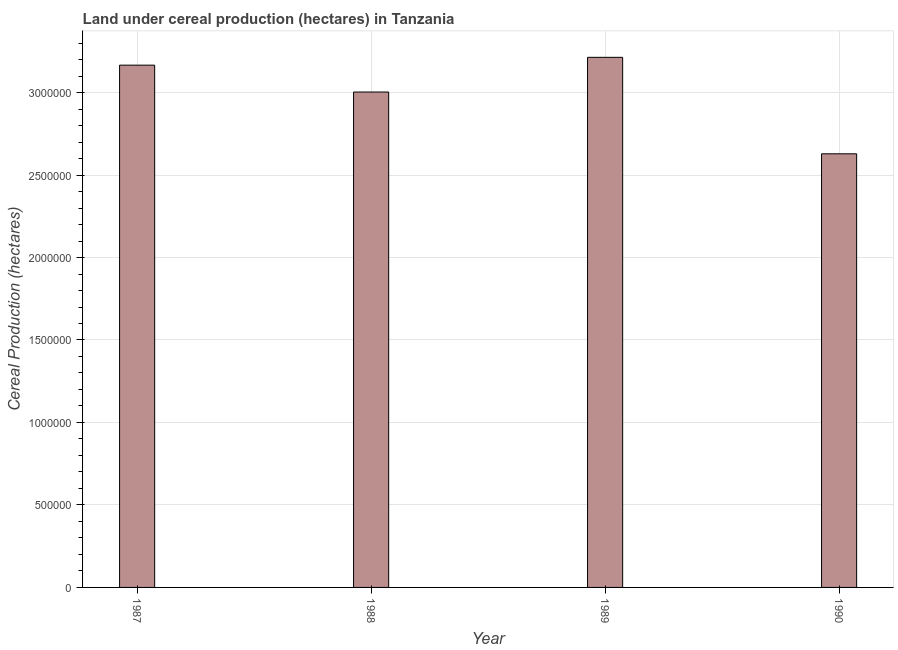Does the graph contain any zero values?
Make the answer very short. No. What is the title of the graph?
Your answer should be very brief. Land under cereal production (hectares) in Tanzania. What is the label or title of the X-axis?
Ensure brevity in your answer.  Year. What is the label or title of the Y-axis?
Keep it short and to the point. Cereal Production (hectares). What is the land under cereal production in 1988?
Ensure brevity in your answer.  3.00e+06. Across all years, what is the maximum land under cereal production?
Make the answer very short. 3.21e+06. Across all years, what is the minimum land under cereal production?
Make the answer very short. 2.63e+06. In which year was the land under cereal production maximum?
Give a very brief answer. 1989. In which year was the land under cereal production minimum?
Provide a short and direct response. 1990. What is the sum of the land under cereal production?
Offer a very short reply. 1.20e+07. What is the difference between the land under cereal production in 1987 and 1989?
Make the answer very short. -4.74e+04. What is the average land under cereal production per year?
Ensure brevity in your answer.  3.00e+06. What is the median land under cereal production?
Your response must be concise. 3.08e+06. What is the ratio of the land under cereal production in 1987 to that in 1988?
Make the answer very short. 1.05. Is the land under cereal production in 1988 less than that in 1989?
Your response must be concise. Yes. Is the difference between the land under cereal production in 1988 and 1990 greater than the difference between any two years?
Ensure brevity in your answer.  No. What is the difference between the highest and the second highest land under cereal production?
Offer a terse response. 4.74e+04. Is the sum of the land under cereal production in 1987 and 1990 greater than the maximum land under cereal production across all years?
Ensure brevity in your answer.  Yes. What is the difference between the highest and the lowest land under cereal production?
Provide a succinct answer. 5.85e+05. Are all the bars in the graph horizontal?
Your answer should be compact. No. How many years are there in the graph?
Make the answer very short. 4. What is the difference between two consecutive major ticks on the Y-axis?
Offer a terse response. 5.00e+05. Are the values on the major ticks of Y-axis written in scientific E-notation?
Provide a short and direct response. No. What is the Cereal Production (hectares) in 1987?
Ensure brevity in your answer.  3.17e+06. What is the Cereal Production (hectares) in 1988?
Provide a succinct answer. 3.00e+06. What is the Cereal Production (hectares) of 1989?
Your answer should be compact. 3.21e+06. What is the Cereal Production (hectares) in 1990?
Keep it short and to the point. 2.63e+06. What is the difference between the Cereal Production (hectares) in 1987 and 1988?
Provide a succinct answer. 1.63e+05. What is the difference between the Cereal Production (hectares) in 1987 and 1989?
Provide a short and direct response. -4.74e+04. What is the difference between the Cereal Production (hectares) in 1987 and 1990?
Your answer should be very brief. 5.37e+05. What is the difference between the Cereal Production (hectares) in 1988 and 1989?
Keep it short and to the point. -2.10e+05. What is the difference between the Cereal Production (hectares) in 1988 and 1990?
Your answer should be compact. 3.75e+05. What is the difference between the Cereal Production (hectares) in 1989 and 1990?
Offer a terse response. 5.85e+05. What is the ratio of the Cereal Production (hectares) in 1987 to that in 1988?
Offer a very short reply. 1.05. What is the ratio of the Cereal Production (hectares) in 1987 to that in 1990?
Give a very brief answer. 1.2. What is the ratio of the Cereal Production (hectares) in 1988 to that in 1989?
Give a very brief answer. 0.94. What is the ratio of the Cereal Production (hectares) in 1988 to that in 1990?
Offer a very short reply. 1.14. What is the ratio of the Cereal Production (hectares) in 1989 to that in 1990?
Keep it short and to the point. 1.22. 